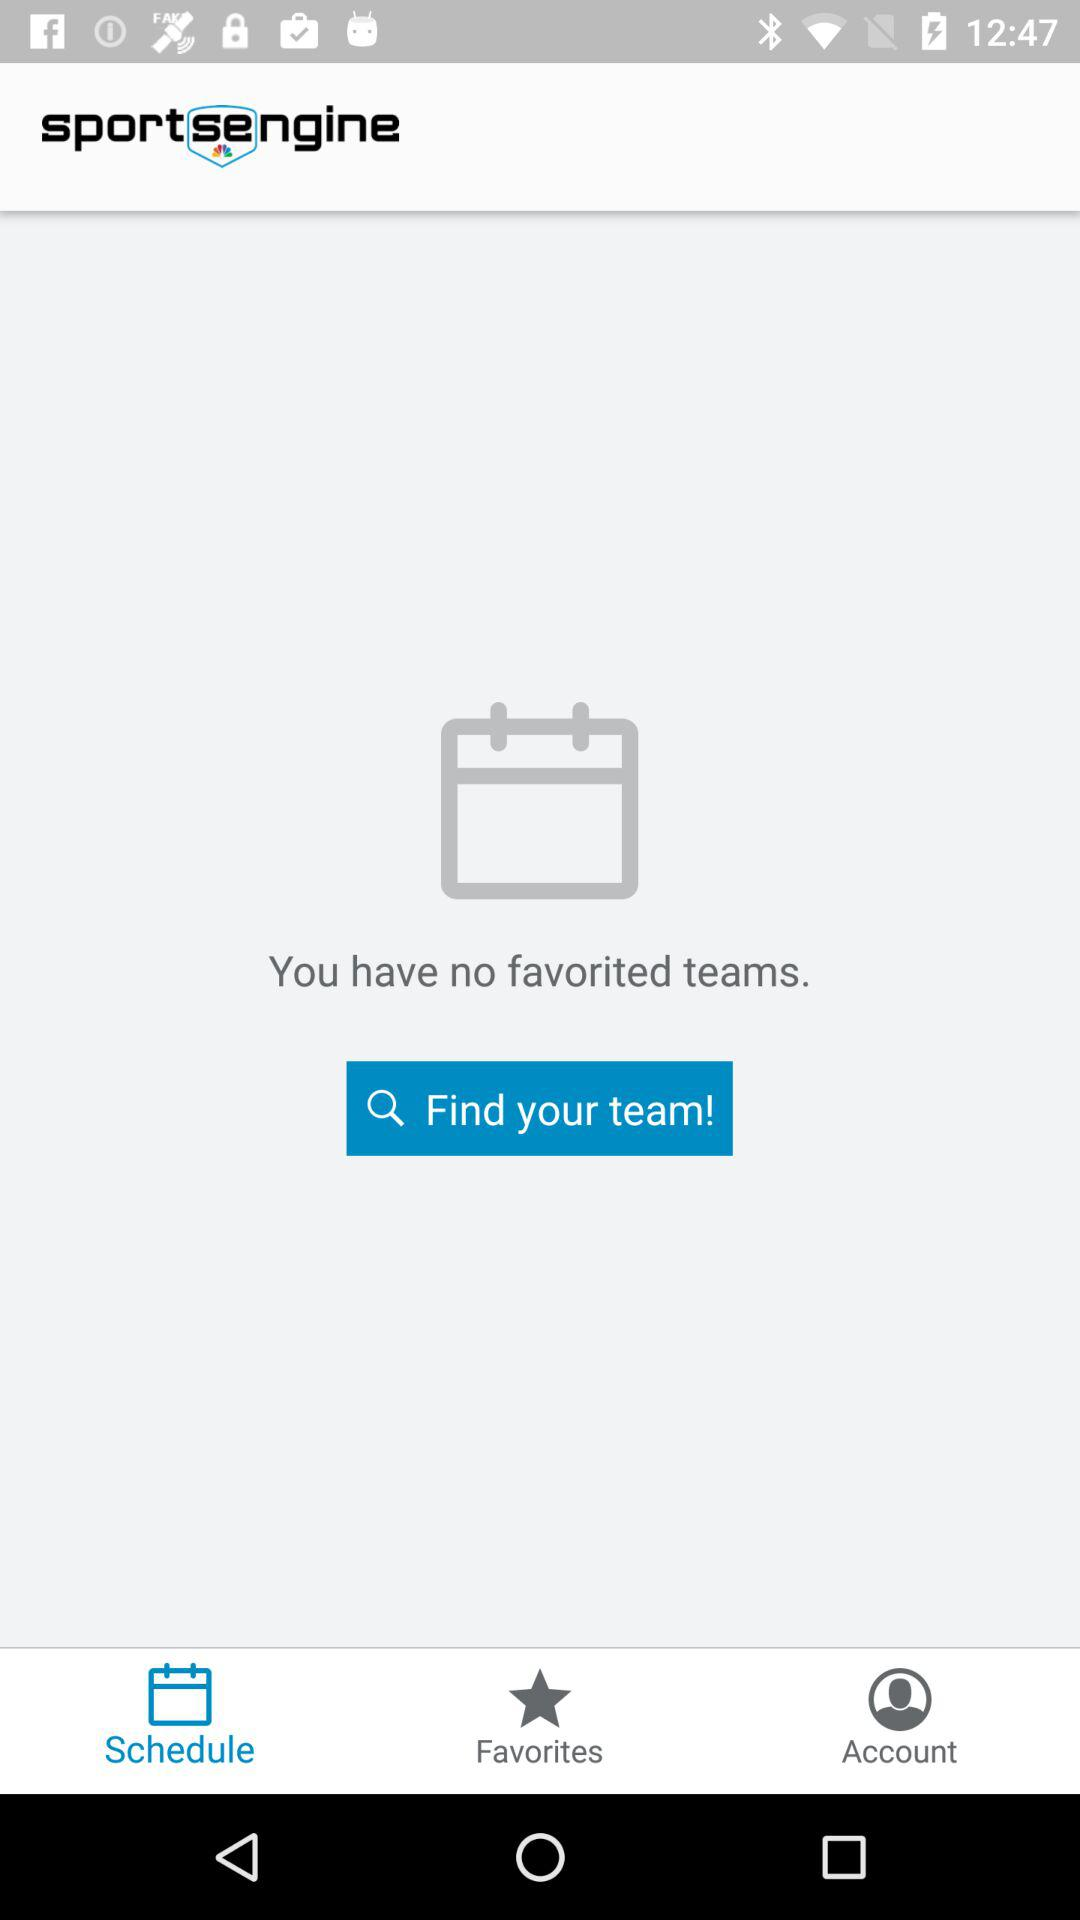What is the name of the application? The name of the application is "sportsengine". 